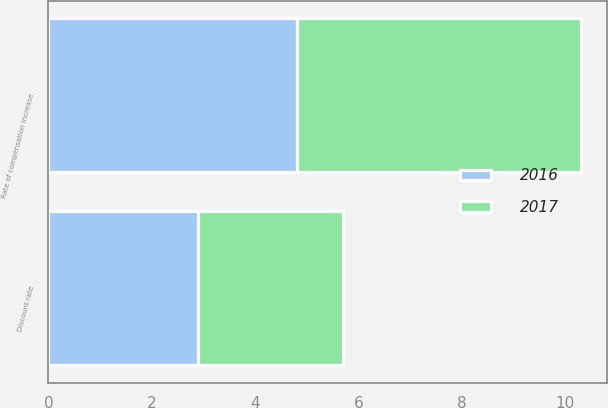<chart> <loc_0><loc_0><loc_500><loc_500><stacked_bar_chart><ecel><fcel>Discount rate<fcel>Rate of compensation increase<nl><fcel>2017<fcel>2.8<fcel>5.5<nl><fcel>2016<fcel>2.9<fcel>4.8<nl></chart> 